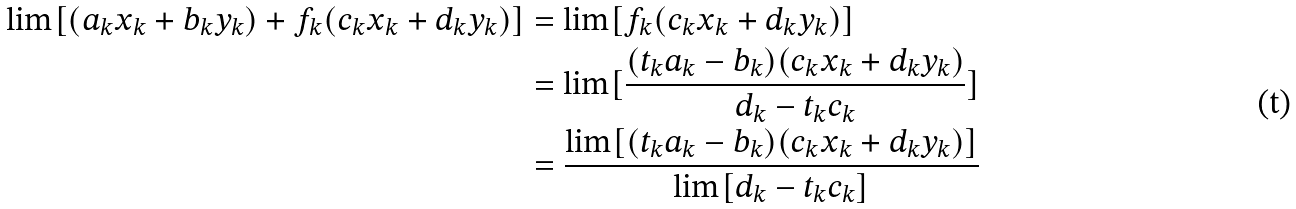Convert formula to latex. <formula><loc_0><loc_0><loc_500><loc_500>\lim [ ( a _ { k } x _ { k } + b _ { k } y _ { k } ) + f _ { k } ( c _ { k } x _ { k } + d _ { k } y _ { k } ) ] & = \lim [ f _ { k } ( c _ { k } x _ { k } + d _ { k } y _ { k } ) ] \\ & = \lim [ \frac { ( t _ { k } a _ { k } - b _ { k } ) ( c _ { k } x _ { k } + d _ { k } y _ { k } ) } { d _ { k } - t _ { k } c _ { k } } ] \\ & = \frac { \lim [ ( t _ { k } a _ { k } - b _ { k } ) ( c _ { k } x _ { k } + d _ { k } y _ { k } ) ] } { \lim [ d _ { k } - t _ { k } c _ { k } ] }</formula> 